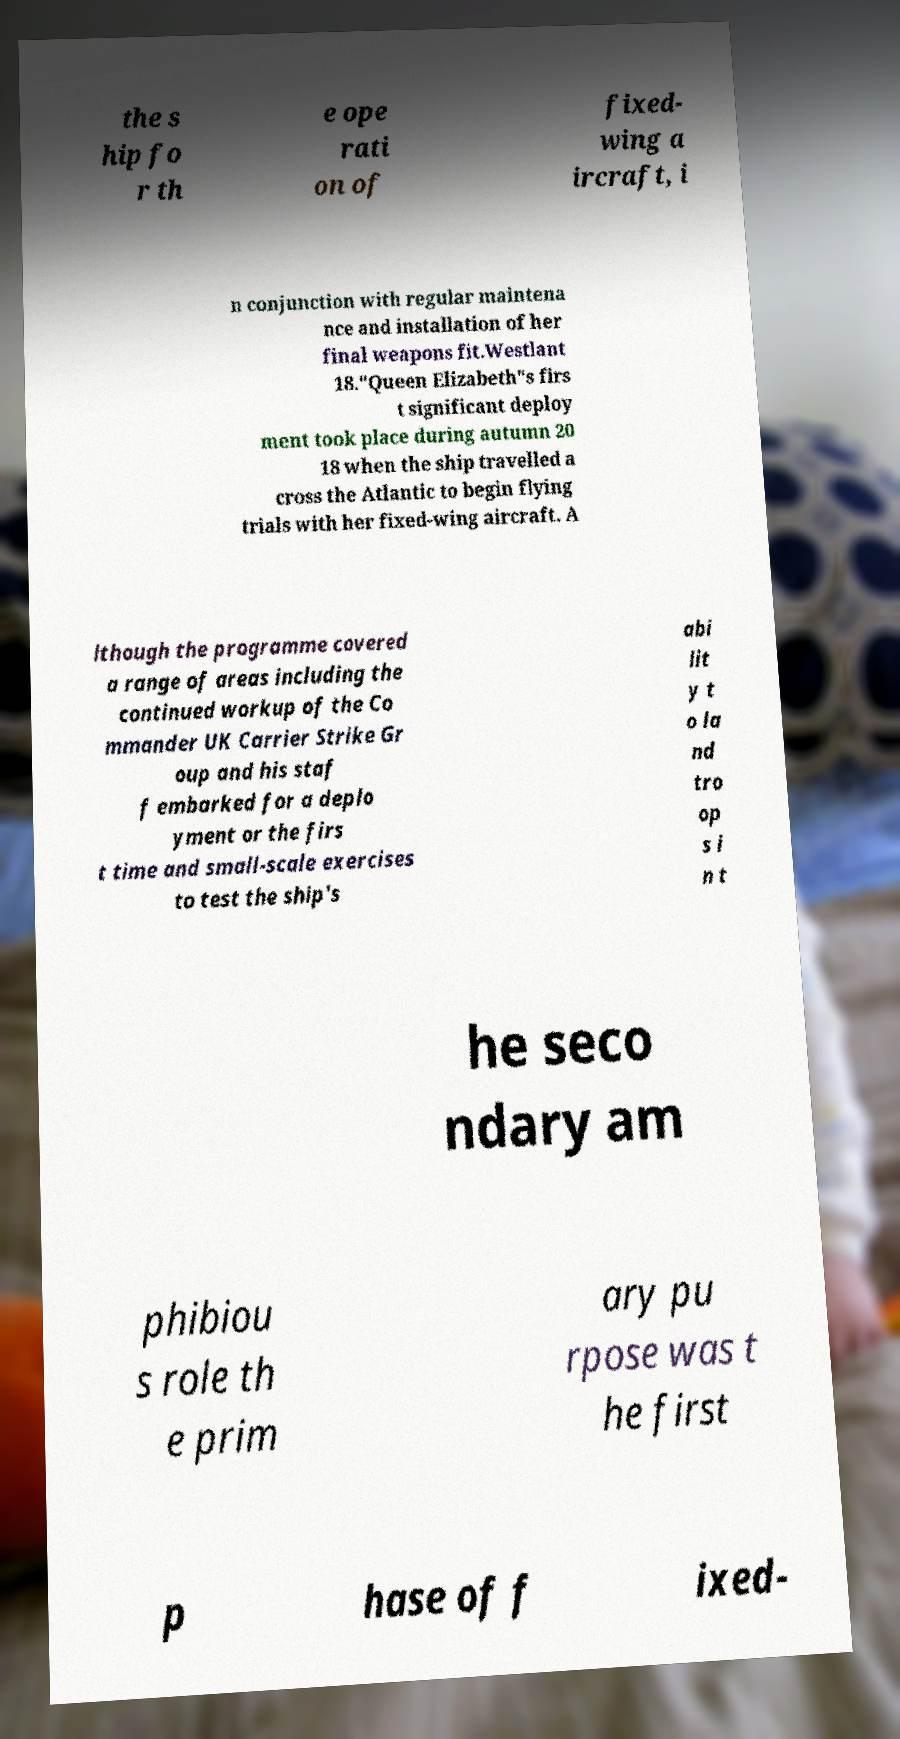Please identify and transcribe the text found in this image. the s hip fo r th e ope rati on of fixed- wing a ircraft, i n conjunction with regular maintena nce and installation of her final weapons fit.Westlant 18."Queen Elizabeth"s firs t significant deploy ment took place during autumn 20 18 when the ship travelled a cross the Atlantic to begin flying trials with her fixed-wing aircraft. A lthough the programme covered a range of areas including the continued workup of the Co mmander UK Carrier Strike Gr oup and his staf f embarked for a deplo yment or the firs t time and small-scale exercises to test the ship's abi lit y t o la nd tro op s i n t he seco ndary am phibiou s role th e prim ary pu rpose was t he first p hase of f ixed- 